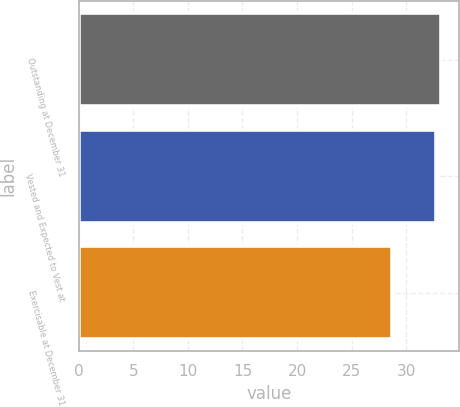Convert chart to OTSL. <chart><loc_0><loc_0><loc_500><loc_500><bar_chart><fcel>Outstanding at December 31<fcel>Vested and Expected to Vest at<fcel>Exercisable at December 31<nl><fcel>33.18<fcel>32.75<fcel>28.71<nl></chart> 